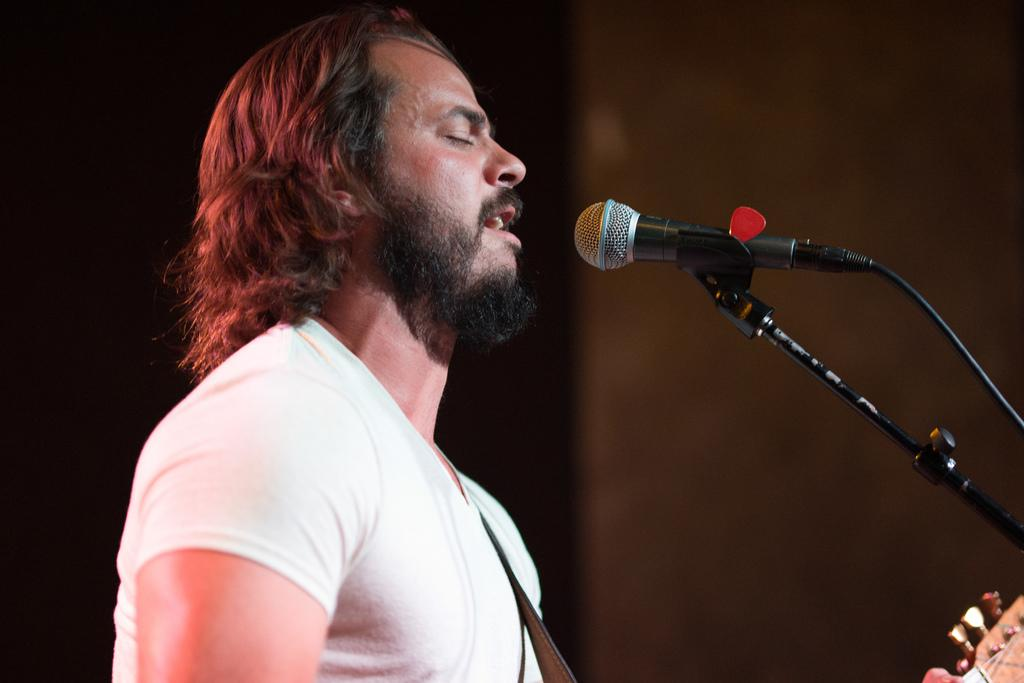What is the person in the image doing? The person is singing. What instrument is the person holding? The person is holding a guitar. What device is present for amplifying the person's voice? There is a microphone in the image. What is in front of the person? There is a stand in front of the person. Can you see any rats swimming in the ocean behind the person in the image? There is no ocean or rats present in the image; it features a person singing with a guitar and a microphone. 